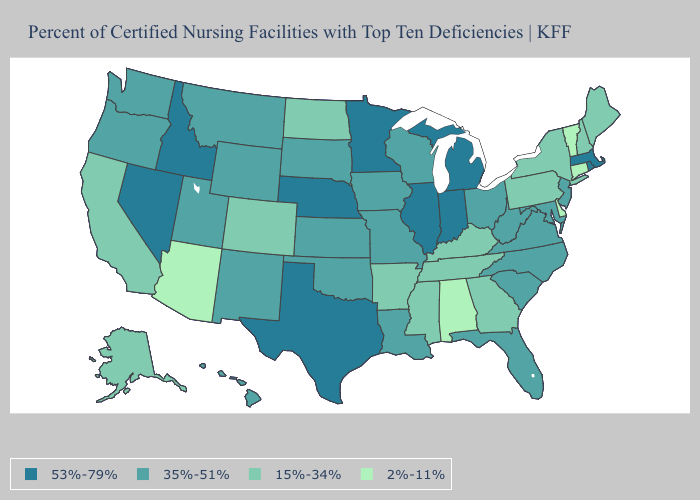Does the map have missing data?
Give a very brief answer. No. Name the states that have a value in the range 15%-34%?
Write a very short answer. Alaska, Arkansas, California, Colorado, Georgia, Kentucky, Maine, Mississippi, New Hampshire, New York, North Dakota, Pennsylvania, Tennessee. Which states hav the highest value in the South?
Concise answer only. Texas. How many symbols are there in the legend?
Write a very short answer. 4. Name the states that have a value in the range 15%-34%?
Write a very short answer. Alaska, Arkansas, California, Colorado, Georgia, Kentucky, Maine, Mississippi, New Hampshire, New York, North Dakota, Pennsylvania, Tennessee. Name the states that have a value in the range 35%-51%?
Give a very brief answer. Florida, Hawaii, Iowa, Kansas, Louisiana, Maryland, Missouri, Montana, New Jersey, New Mexico, North Carolina, Ohio, Oklahoma, Oregon, South Carolina, South Dakota, Utah, Virginia, Washington, West Virginia, Wisconsin, Wyoming. Does the map have missing data?
Answer briefly. No. What is the lowest value in the USA?
Concise answer only. 2%-11%. Which states have the lowest value in the USA?
Write a very short answer. Alabama, Arizona, Connecticut, Delaware, Vermont. Among the states that border Oregon , which have the highest value?
Short answer required. Idaho, Nevada. Does North Dakota have the same value as New York?
Write a very short answer. Yes. Name the states that have a value in the range 35%-51%?
Answer briefly. Florida, Hawaii, Iowa, Kansas, Louisiana, Maryland, Missouri, Montana, New Jersey, New Mexico, North Carolina, Ohio, Oklahoma, Oregon, South Carolina, South Dakota, Utah, Virginia, Washington, West Virginia, Wisconsin, Wyoming. Name the states that have a value in the range 35%-51%?
Be succinct. Florida, Hawaii, Iowa, Kansas, Louisiana, Maryland, Missouri, Montana, New Jersey, New Mexico, North Carolina, Ohio, Oklahoma, Oregon, South Carolina, South Dakota, Utah, Virginia, Washington, West Virginia, Wisconsin, Wyoming. Does South Dakota have the lowest value in the MidWest?
Quick response, please. No. 